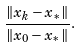Convert formula to latex. <formula><loc_0><loc_0><loc_500><loc_500>\frac { \| x _ { k } - x _ { * } \| } { \| x _ { 0 } - x _ { * } \| } .</formula> 